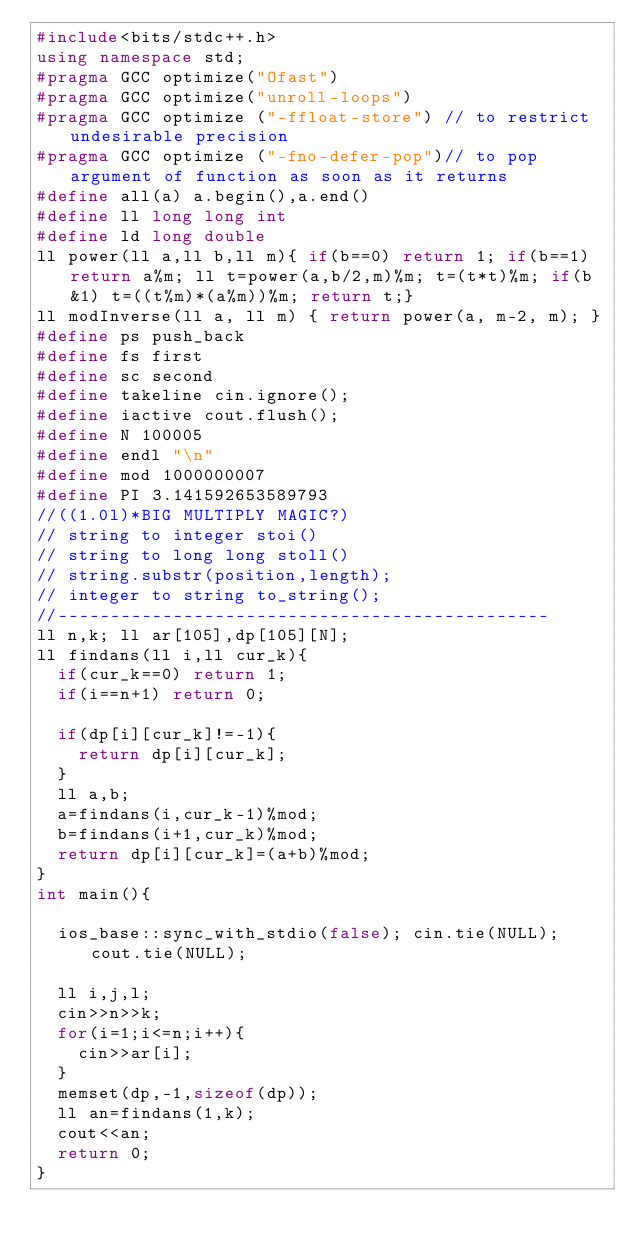<code> <loc_0><loc_0><loc_500><loc_500><_C++_>#include<bits/stdc++.h>
using namespace std;
#pragma GCC optimize("Ofast")
#pragma GCC optimize("unroll-loops")
#pragma GCC optimize ("-ffloat-store") // to restrict undesirable precision
#pragma GCC optimize ("-fno-defer-pop")// to pop argument of function as soon as it returns
#define all(a) a.begin(),a.end()
#define ll long long int
#define ld long double
ll power(ll a,ll b,ll m){ if(b==0) return 1; if(b==1) return a%m; ll t=power(a,b/2,m)%m; t=(t*t)%m; if(b&1) t=((t%m)*(a%m))%m; return t;}
ll modInverse(ll a, ll m) { return power(a, m-2, m); }
#define ps push_back
#define fs first
#define sc second
#define takeline cin.ignore();
#define iactive cout.flush();
#define N 100005
#define endl "\n"
#define mod 1000000007
#define PI 3.141592653589793
//((1.0l)*BIG MULTIPLY MAGIC?)
// string to integer stoi()
// string to long long stoll()
// string.substr(position,length);
// integer to string to_string();
//-----------------------------------------------
ll n,k; ll ar[105],dp[105][N];
ll findans(ll i,ll cur_k){
	if(cur_k==0) return 1;
	if(i==n+1) return 0;

	if(dp[i][cur_k]!=-1){
		return dp[i][cur_k];
	}
	ll a,b;
	a=findans(i,cur_k-1)%mod;
	b=findans(i+1,cur_k)%mod;
	return dp[i][cur_k]=(a+b)%mod;
}
int main(){

	ios_base::sync_with_stdio(false); cin.tie(NULL); cout.tie(NULL);
	
	ll i,j,l;
	cin>>n>>k;
	for(i=1;i<=n;i++){
		cin>>ar[i];
	}
	memset(dp,-1,sizeof(dp));
	ll an=findans(1,k);
	cout<<an;
	return 0;
}</code> 